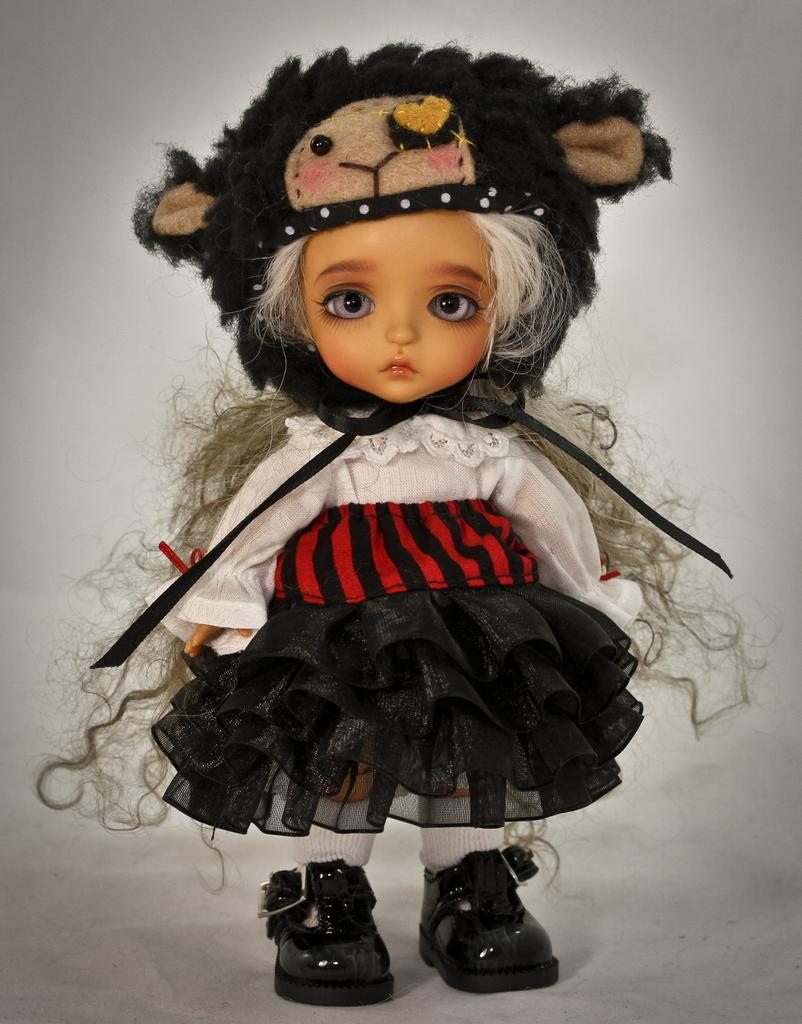What object can be seen in the image? There is a toy in the image. What color is the background of the image? The background of the image is white. Is there a receipt for the toy visible in the image? There is no receipt present in the image. Can you see the toy's uncle in the image? There is no person, including an uncle, present in the image. What is the condition of the roof in the image? There is no roof present in the image, as it is a close-up of a toy against a white background. 